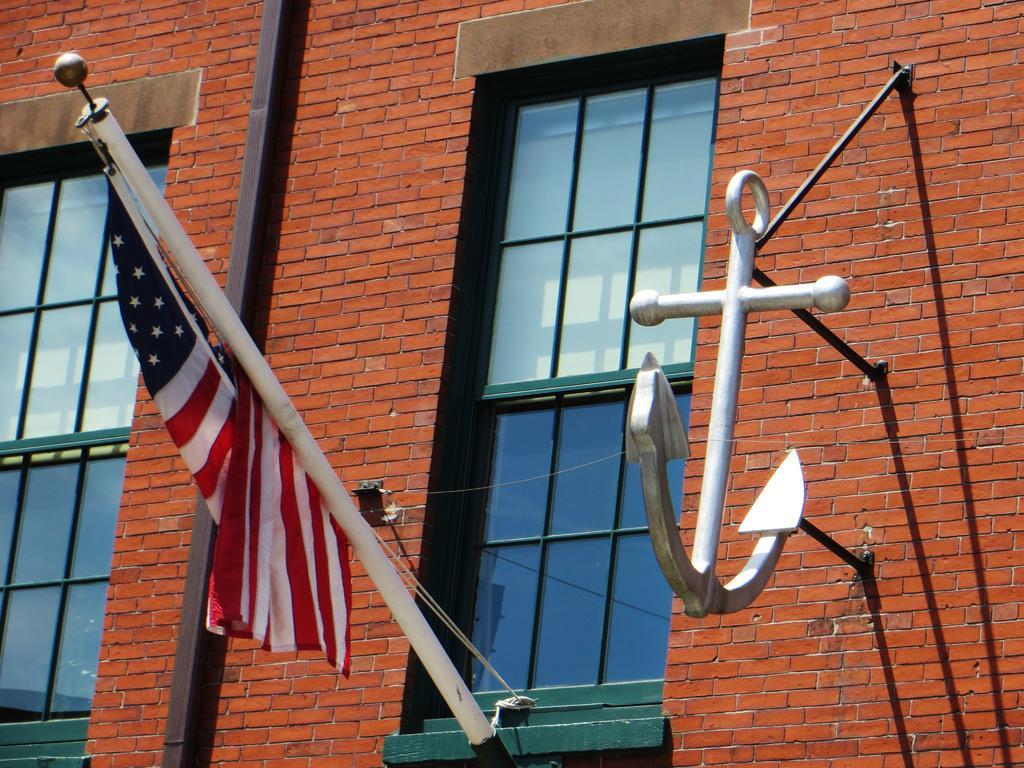Describe this image in one or two sentences. This looks like a building with the windows. I can see a flag hanging to a pole. This looks like an anchor, which is attached to the wall. These are the glass doors. This looks like a pole. 